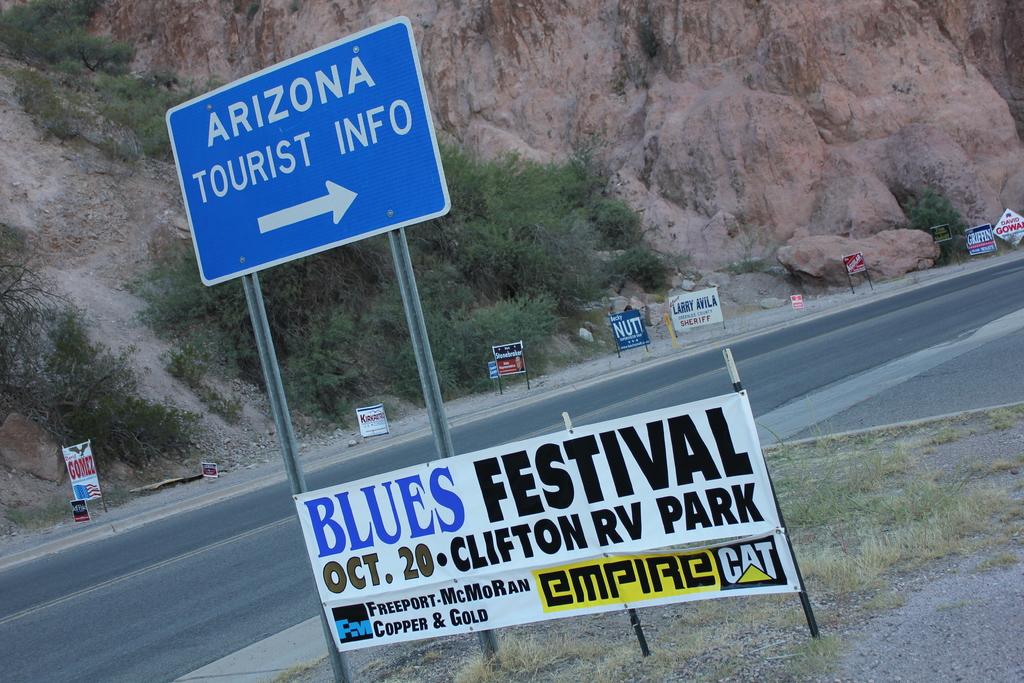Where will the blues festival take place?
Your answer should be compact. Clifton rv park. When does the blues festival take place?
Make the answer very short. Oct 20. 